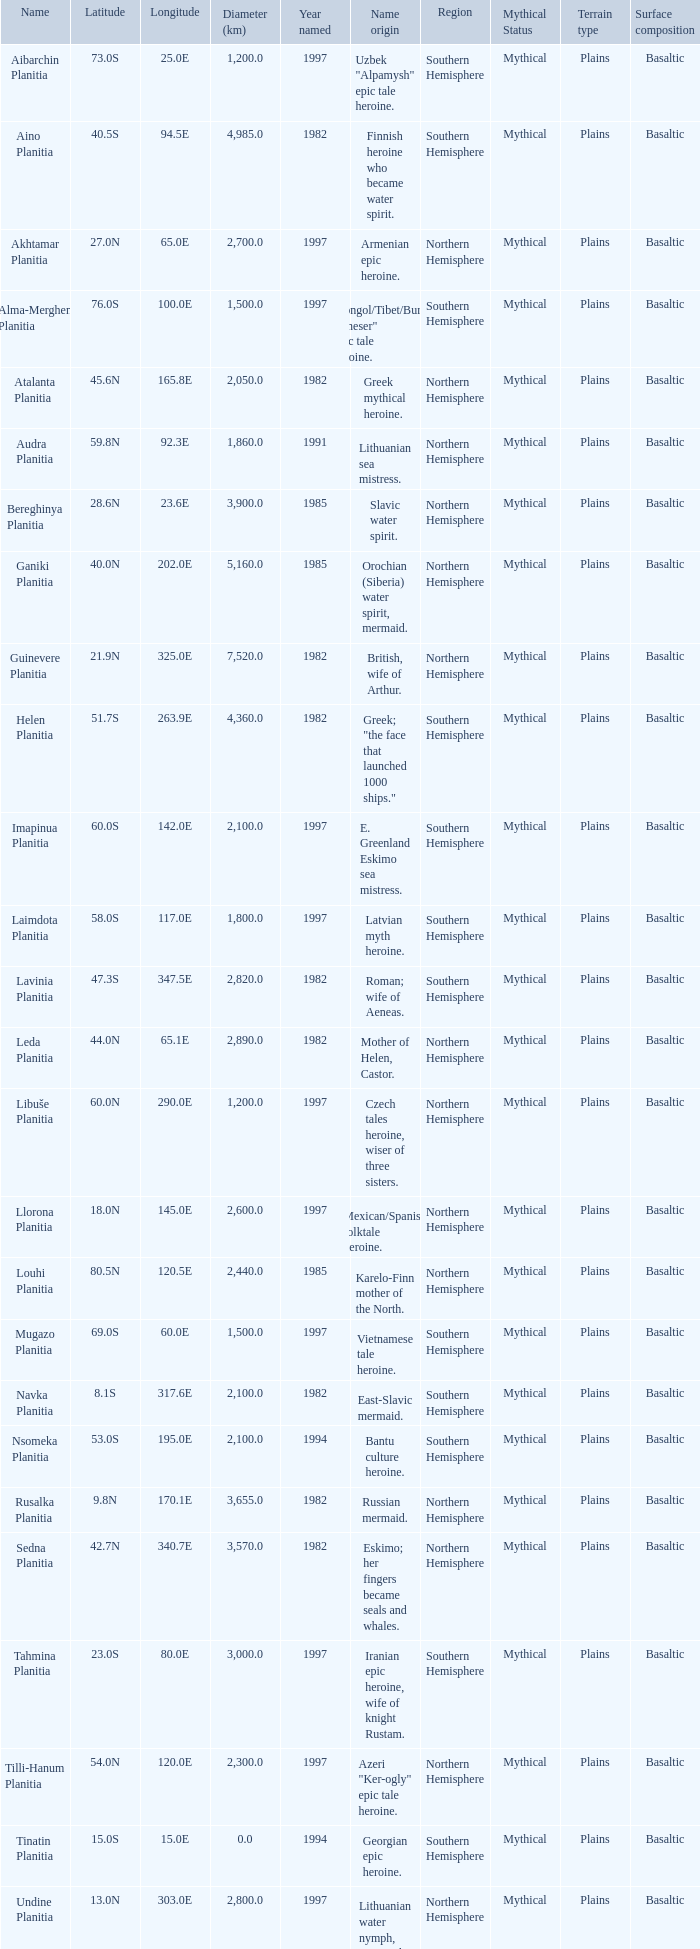Parse the full table. {'header': ['Name', 'Latitude', 'Longitude', 'Diameter (km)', 'Year named', 'Name origin', 'Region', 'Mythical Status', 'Terrain type', 'Surface composition '], 'rows': [['Aibarchin Planitia', '73.0S', '25.0E', '1,200.0', '1997', 'Uzbek "Alpamysh" epic tale heroine.', 'Southern Hemisphere', 'Mythical', 'Plains', 'Basaltic'], ['Aino Planitia', '40.5S', '94.5E', '4,985.0', '1982', 'Finnish heroine who became water spirit.', 'Southern Hemisphere', 'Mythical', 'Plains', 'Basaltic'], ['Akhtamar Planitia', '27.0N', '65.0E', '2,700.0', '1997', 'Armenian epic heroine.', 'Northern Hemisphere', 'Mythical', 'Plains', 'Basaltic'], ['Alma-Merghen Planitia', '76.0S', '100.0E', '1,500.0', '1997', 'Mongol/Tibet/Buryat "Gheser" epic tale heroine.', 'Southern Hemisphere', 'Mythical', 'Plains', 'Basaltic'], ['Atalanta Planitia', '45.6N', '165.8E', '2,050.0', '1982', 'Greek mythical heroine.', 'Northern Hemisphere', 'Mythical', 'Plains', 'Basaltic'], ['Audra Planitia', '59.8N', '92.3E', '1,860.0', '1991', 'Lithuanian sea mistress.', 'Northern Hemisphere', 'Mythical', 'Plains', 'Basaltic'], ['Bereghinya Planitia', '28.6N', '23.6E', '3,900.0', '1985', 'Slavic water spirit.', 'Northern Hemisphere', 'Mythical', 'Plains', 'Basaltic'], ['Ganiki Planitia', '40.0N', '202.0E', '5,160.0', '1985', 'Orochian (Siberia) water spirit, mermaid.', 'Northern Hemisphere', 'Mythical', 'Plains', 'Basaltic'], ['Guinevere Planitia', '21.9N', '325.0E', '7,520.0', '1982', 'British, wife of Arthur.', 'Northern Hemisphere', 'Mythical', 'Plains', 'Basaltic'], ['Helen Planitia', '51.7S', '263.9E', '4,360.0', '1982', 'Greek; "the face that launched 1000 ships."', 'Southern Hemisphere', 'Mythical', 'Plains', 'Basaltic'], ['Imapinua Planitia', '60.0S', '142.0E', '2,100.0', '1997', 'E. Greenland Eskimo sea mistress.', 'Southern Hemisphere', 'Mythical', 'Plains', 'Basaltic'], ['Laimdota Planitia', '58.0S', '117.0E', '1,800.0', '1997', 'Latvian myth heroine.', 'Southern Hemisphere', 'Mythical', 'Plains', 'Basaltic'], ['Lavinia Planitia', '47.3S', '347.5E', '2,820.0', '1982', 'Roman; wife of Aeneas.', 'Southern Hemisphere', 'Mythical', 'Plains', 'Basaltic'], ['Leda Planitia', '44.0N', '65.1E', '2,890.0', '1982', 'Mother of Helen, Castor.', 'Northern Hemisphere', 'Mythical', 'Plains', 'Basaltic'], ['Libuše Planitia', '60.0N', '290.0E', '1,200.0', '1997', 'Czech tales heroine, wiser of three sisters.', 'Northern Hemisphere', 'Mythical', 'Plains', 'Basaltic'], ['Llorona Planitia', '18.0N', '145.0E', '2,600.0', '1997', 'Mexican/Spanish folktale heroine.', 'Northern Hemisphere', 'Mythical', 'Plains', 'Basaltic'], ['Louhi Planitia', '80.5N', '120.5E', '2,440.0', '1985', 'Karelo-Finn mother of the North.', 'Northern Hemisphere', 'Mythical', 'Plains', 'Basaltic'], ['Mugazo Planitia', '69.0S', '60.0E', '1,500.0', '1997', 'Vietnamese tale heroine.', 'Southern Hemisphere', 'Mythical', 'Plains', 'Basaltic'], ['Navka Planitia', '8.1S', '317.6E', '2,100.0', '1982', 'East-Slavic mermaid.', 'Southern Hemisphere', 'Mythical', 'Plains', 'Basaltic'], ['Nsomeka Planitia', '53.0S', '195.0E', '2,100.0', '1994', 'Bantu culture heroine.', 'Southern Hemisphere', 'Mythical', 'Plains', 'Basaltic'], ['Rusalka Planitia', '9.8N', '170.1E', '3,655.0', '1982', 'Russian mermaid.', 'Northern Hemisphere', 'Mythical', 'Plains', 'Basaltic'], ['Sedna Planitia', '42.7N', '340.7E', '3,570.0', '1982', 'Eskimo; her fingers became seals and whales.', 'Northern Hemisphere', 'Mythical', 'Plains', 'Basaltic'], ['Tahmina Planitia', '23.0S', '80.0E', '3,000.0', '1997', 'Iranian epic heroine, wife of knight Rustam.', 'Southern Hemisphere', 'Mythical', 'Plains', 'Basaltic'], ['Tilli-Hanum Planitia', '54.0N', '120.0E', '2,300.0', '1997', 'Azeri "Ker-ogly" epic tale heroine.', 'Northern Hemisphere', 'Mythical', 'Plains', 'Basaltic'], ['Tinatin Planitia', '15.0S', '15.0E', '0.0', '1994', 'Georgian epic heroine.', 'Southern Hemisphere', 'Mythical', 'Plains', 'Basaltic'], ['Undine Planitia', '13.0N', '303.0E', '2,800.0', '1997', 'Lithuanian water nymph, mermaid.', 'Northern Hemisphere', 'Mythical', 'Plains', 'Basaltic'], ['Vellamo Planitia', '45.4N', '149.1E', '2,155.0', '1985', 'Karelo-Finn mermaid.', 'Northern Hemisphere', 'Mythical', 'Plains', 'Basaltic']]} What's the name origin of feature of diameter (km) 2,155.0 Karelo-Finn mermaid. 